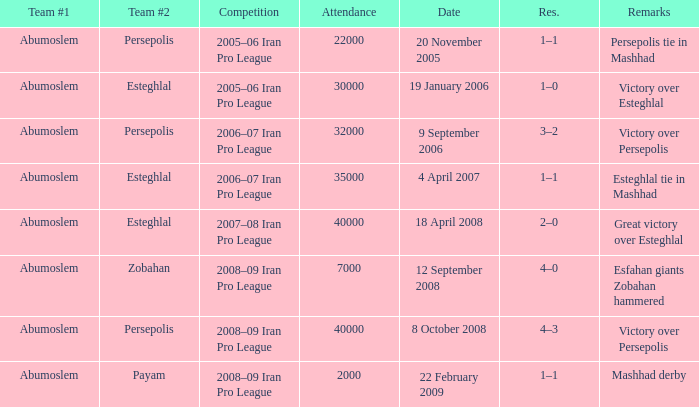Who was team #1 on 9 September 2006? Abumoslem. 